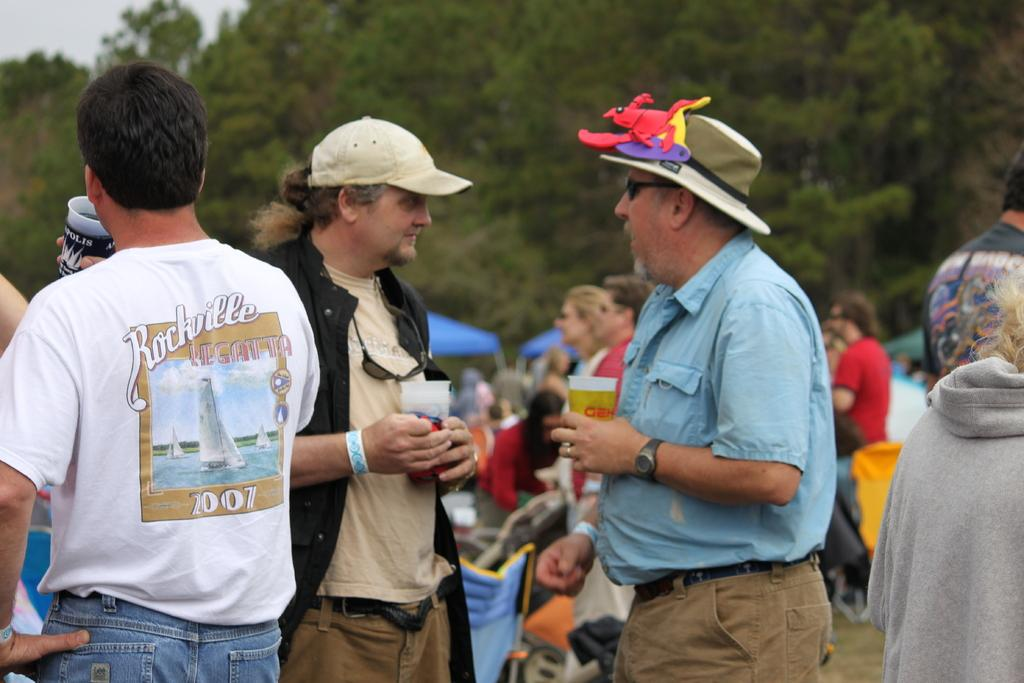What are the people in the middle of the image doing? The people in the middle of the image are standing and sitting, and they are holding cups. What can be seen behind the people in the image? There are tents and trees behind the people in the image. Can you hear the people in the image laughing while they are holding the screws? There is no mention of laughter or screws in the image, so we cannot determine if the people are laughing or holding screws. 